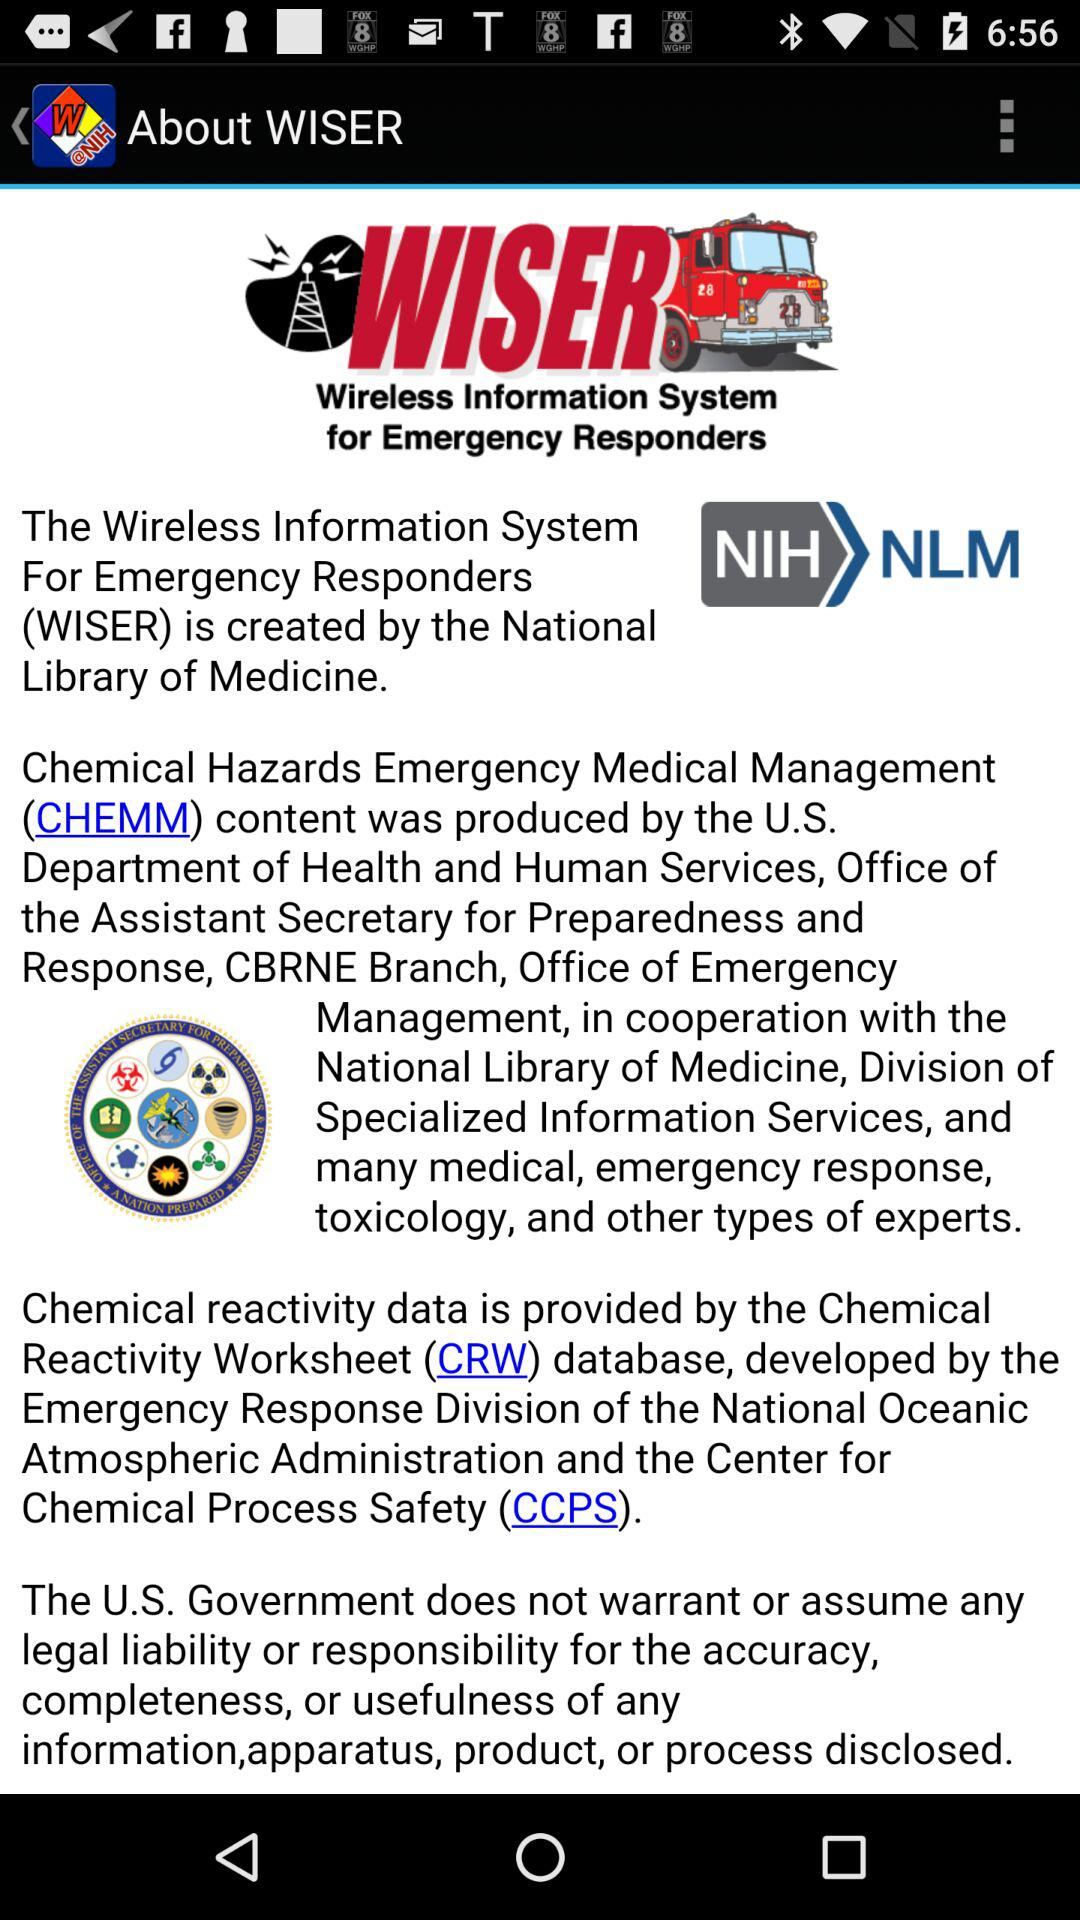Who developed the Chemical Reactivity Worksheet database? The Chemical Reactivity Worksheet database was developed by the Emergency Response Division of the National Oceanic Atmospheric Administration and the Center for Chemical Process Safety (CCPS). 